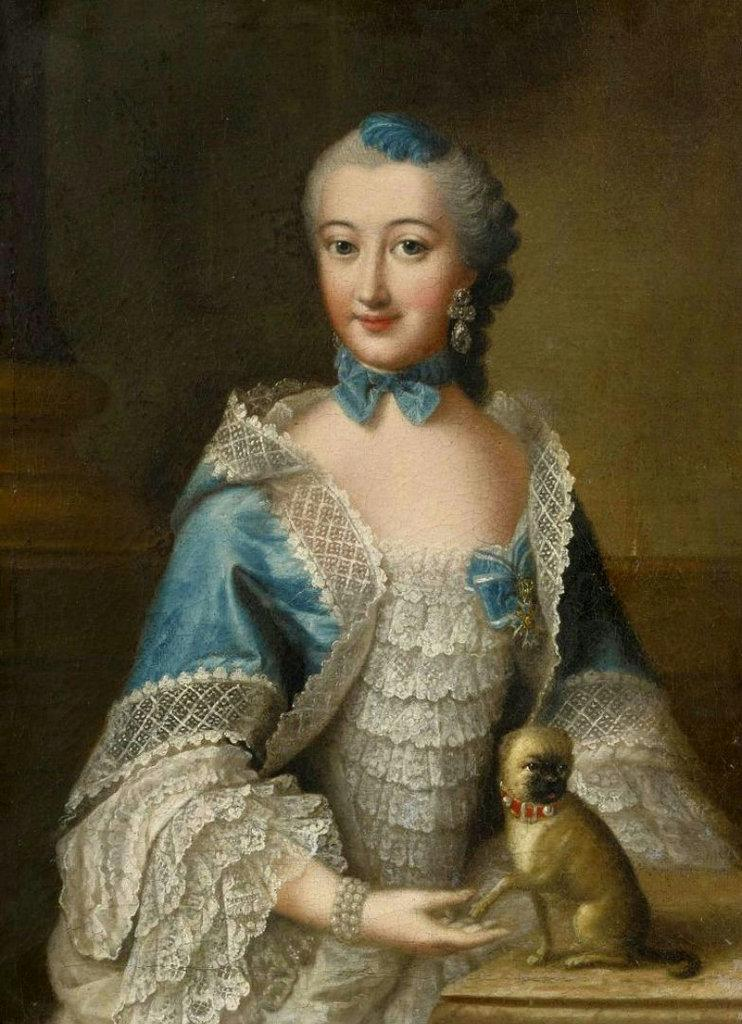What type of artwork is depicted in the image? The image is a painting. Who or what is the main subject of the painting? There is a woman in the painting. What is the woman wearing? The woman is wearing a blue and white dress. Are there any other living creatures in the painting? Yes, there is a dog in the painting. Where is the dog located in the painting? The dog is sitting on a table. What can be seen in the background of the painting? There is a wall in the background of the painting. What type of trouble is the dog causing in the painting? There is no indication of trouble or any problematic behavior involving the dog in the painting. 